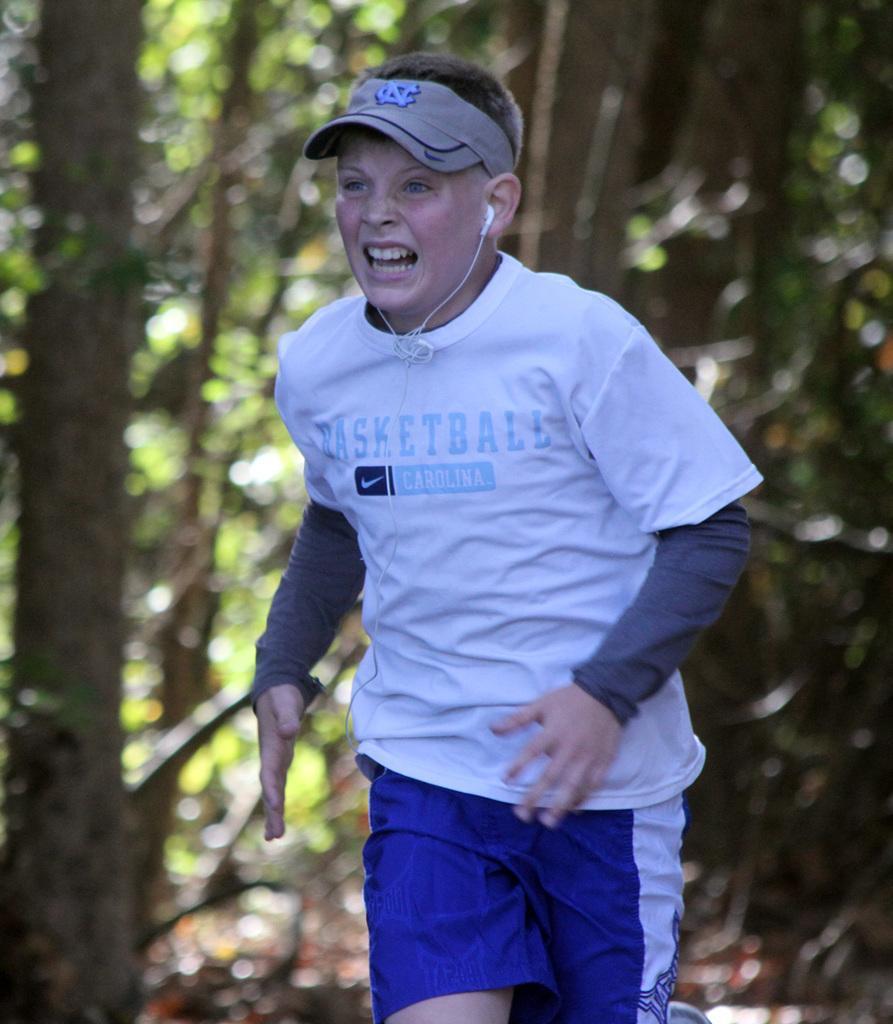Describe this image in one or two sentences. In this image we can see a person. There are many trees in the image. A person wearing a cap. There is some text on the T-shirt. There is a blur background in the image. 